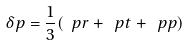Convert formula to latex. <formula><loc_0><loc_0><loc_500><loc_500>\delta p = \frac { 1 } { 3 } ( \ p r + \ p t + \ p p )</formula> 